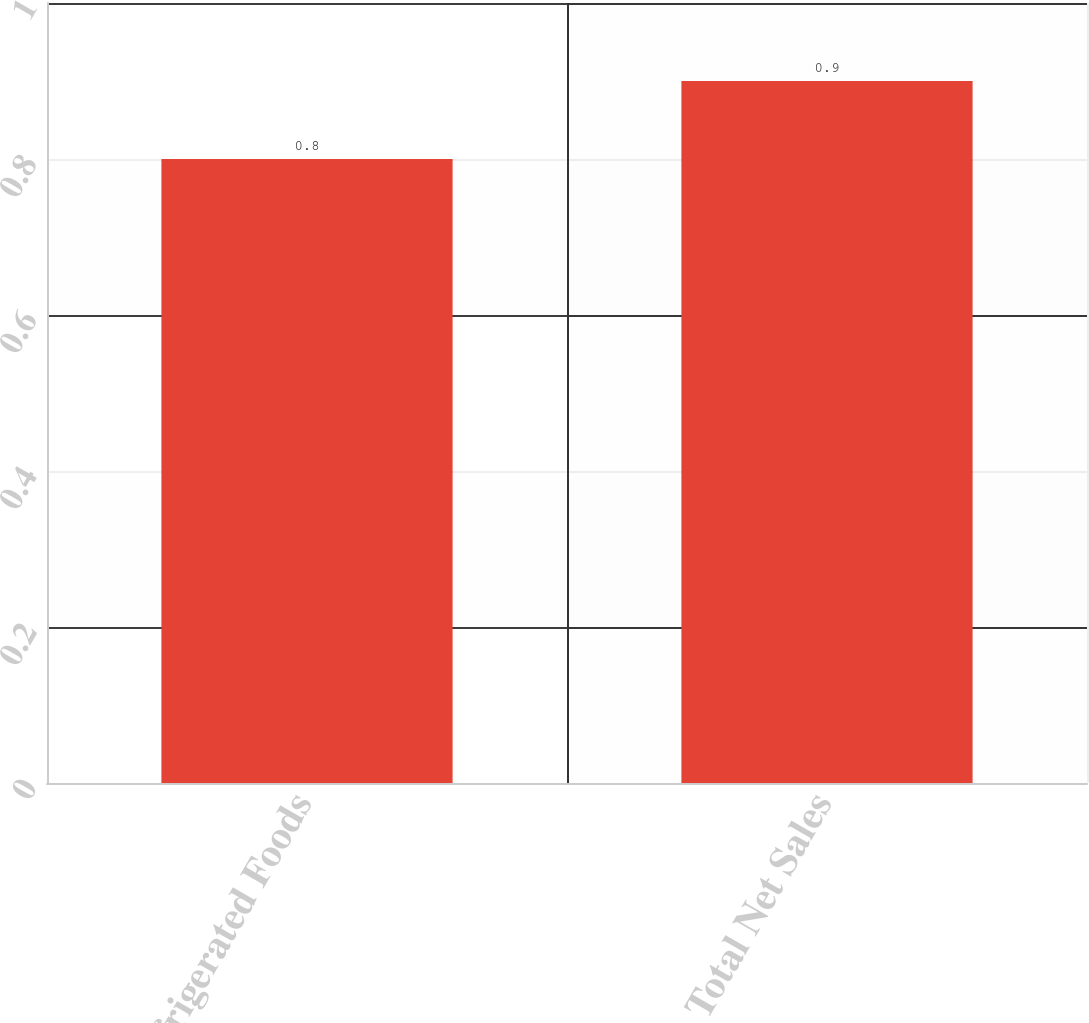Convert chart to OTSL. <chart><loc_0><loc_0><loc_500><loc_500><bar_chart><fcel>Refrigerated Foods<fcel>Total Net Sales<nl><fcel>0.8<fcel>0.9<nl></chart> 